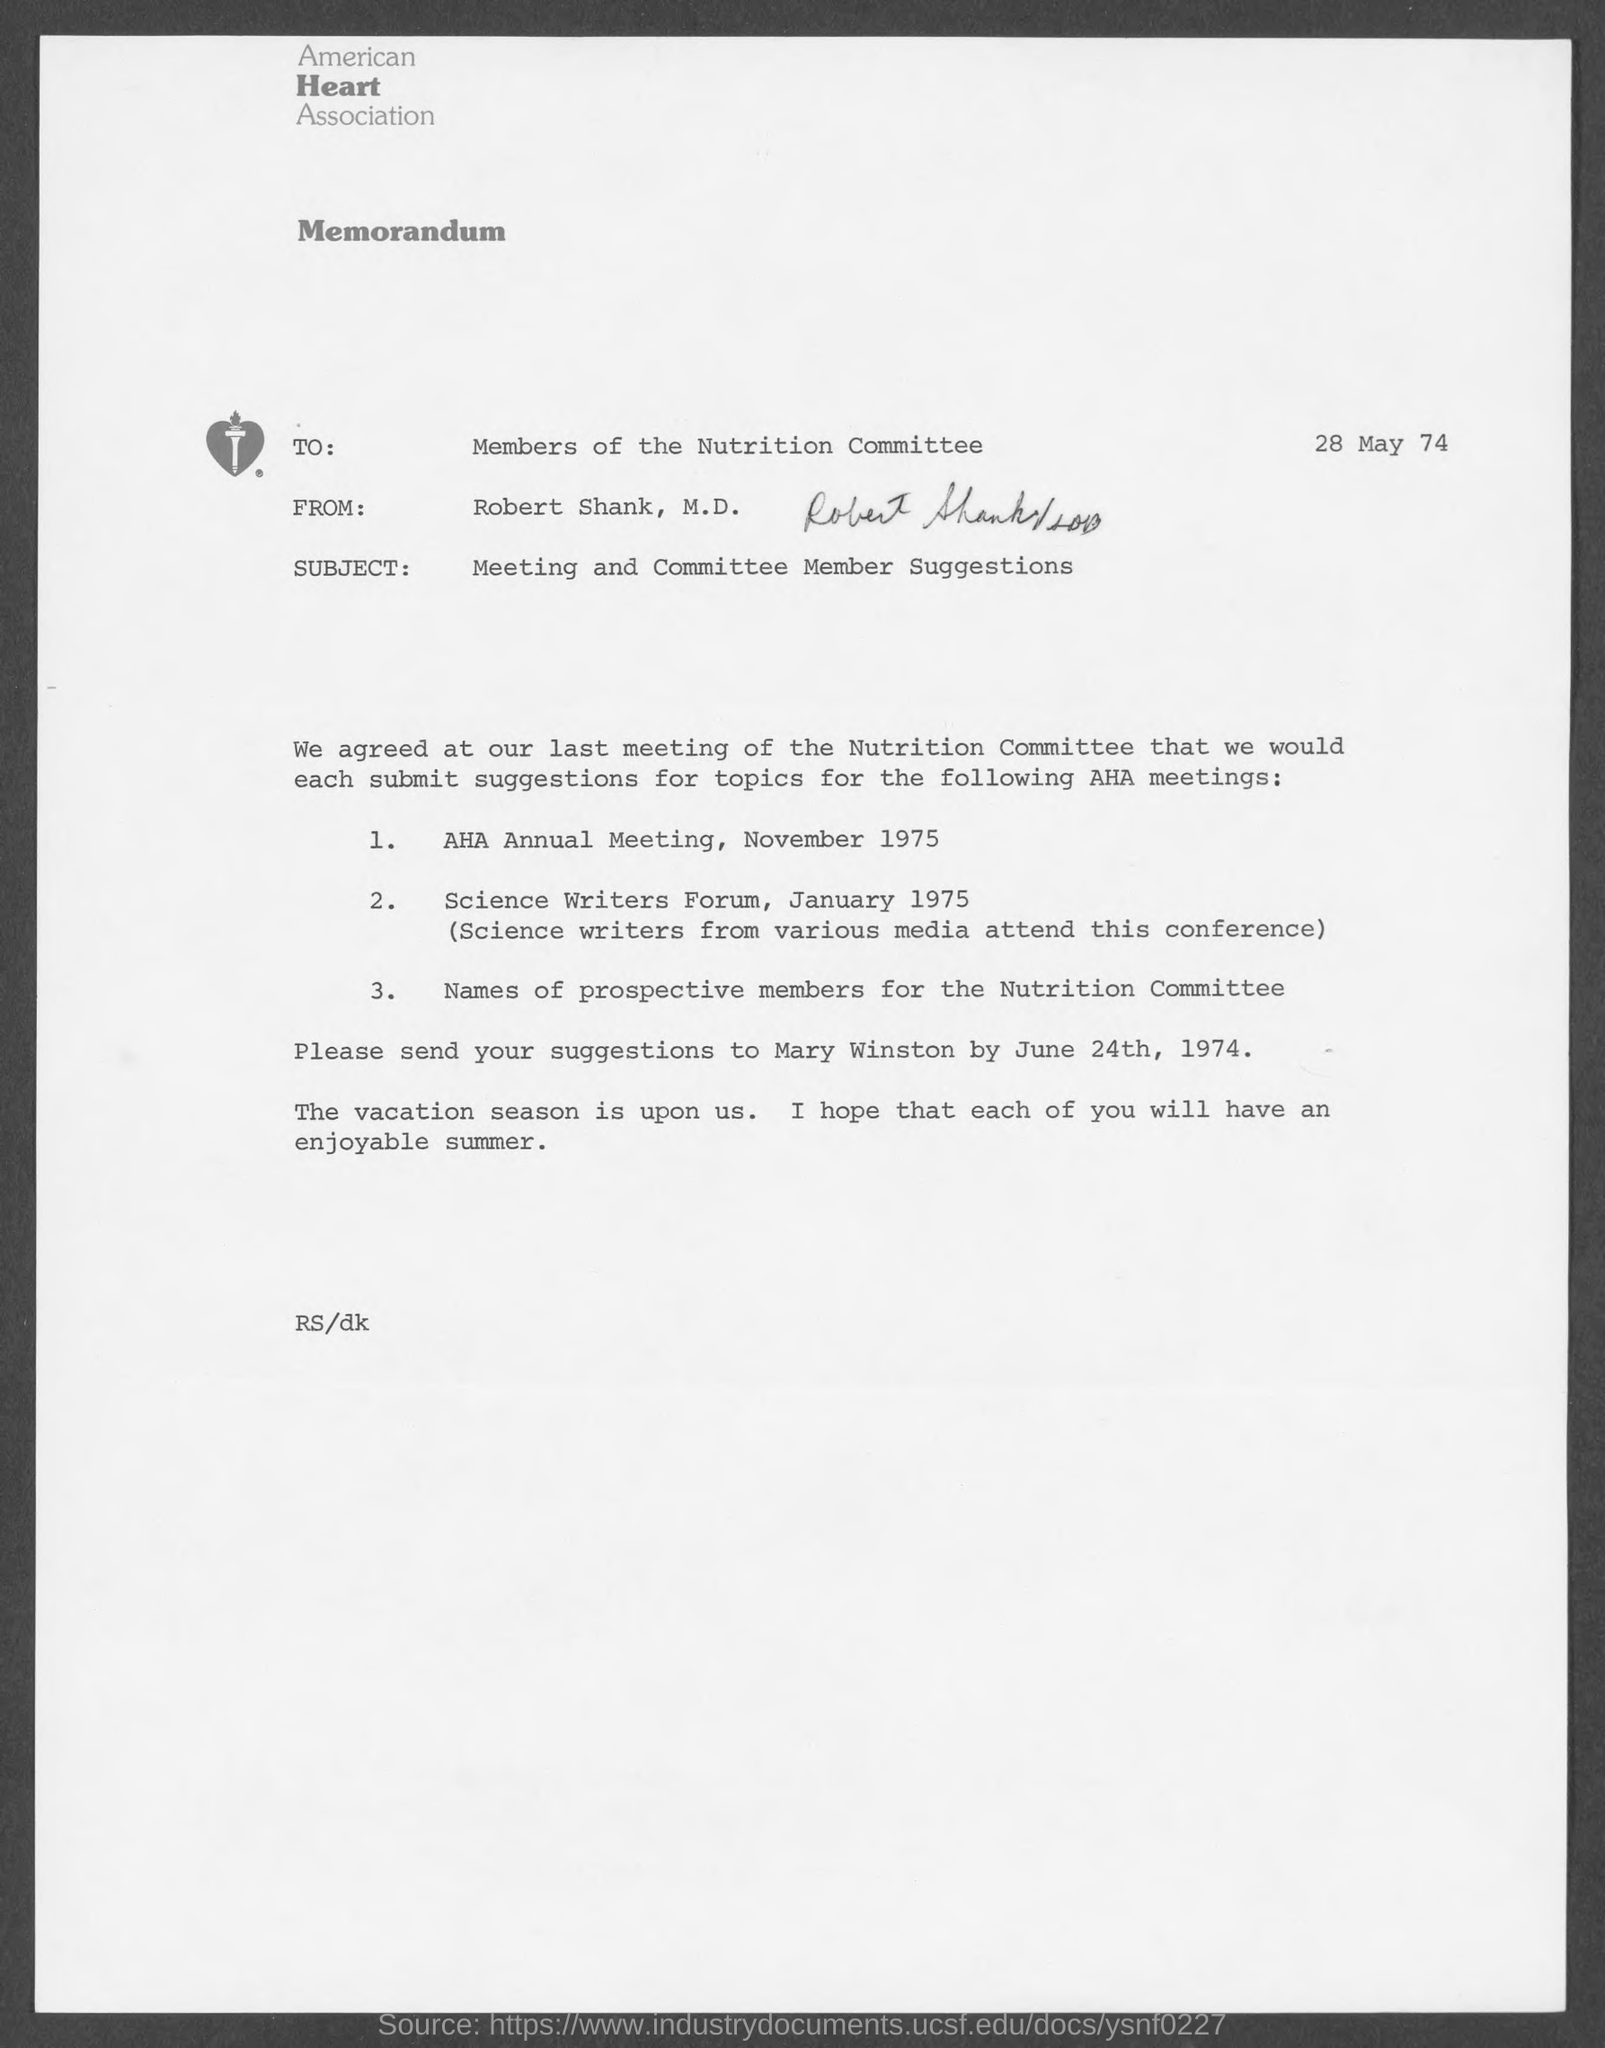What is the name of the heart association at top of the page ?
Offer a terse response. American Heart Association. When is the memorandum dated?
Give a very brief answer. 28 May 74. What is the subject of memorandum ?
Your answer should be compact. Meeting and Committee Member Suggestions. What is the from address in memorandum ?
Your response must be concise. Robert Shank, M.D. When is the aha annual meeting scheduled on ?
Make the answer very short. November 1975. When is the science writers forum on ?
Your response must be concise. January 1975. 